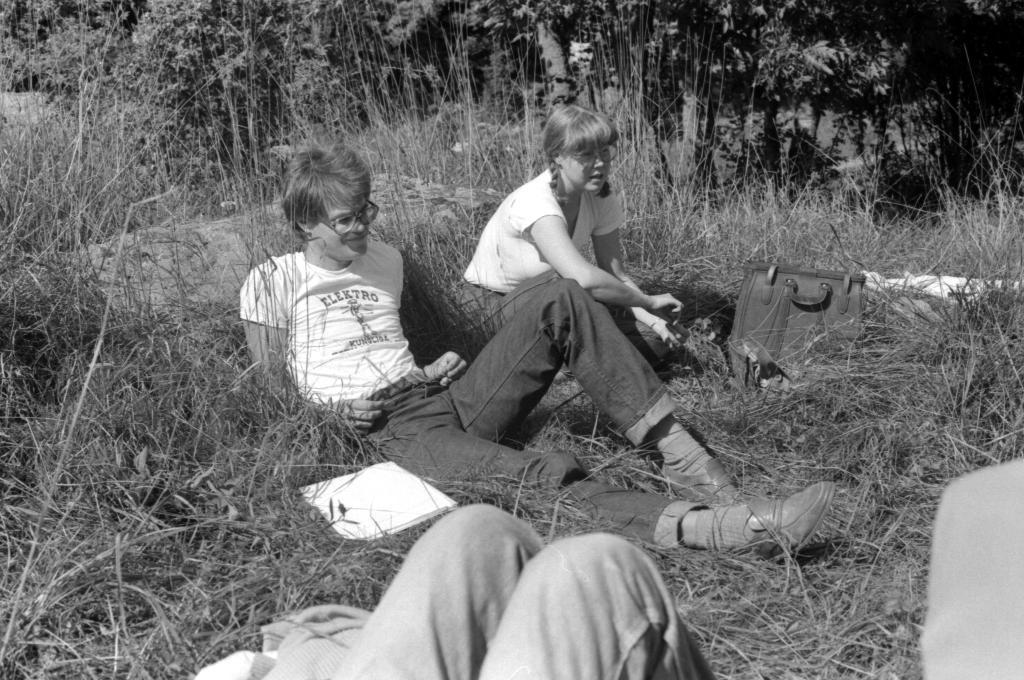What is the color scheme of the image? The image is black and white. How many people are in the image? There are three people in the image. What is the surface the people are standing on? The people are on a grass surface. What is in front of one of the women? There is a bag in front of one of the women. What can be seen behind the people? There are trees behind the people. What type of produce is being harvested by the people in the image? There is no produce or harvesting activity depicted in the image; it features three people standing on a grass surface with trees in the background. What news headline is being discussed by the people in the image? There is no indication of a discussion or news in the image; it simply shows three people on a grass surface with trees in the background. 